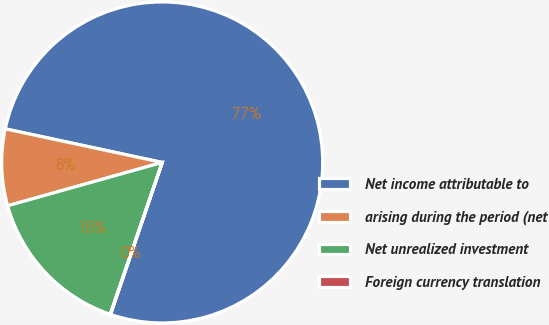<chart> <loc_0><loc_0><loc_500><loc_500><pie_chart><fcel>Net income attributable to<fcel>arising during the period (net<fcel>Net unrealized investment<fcel>Foreign currency translation<nl><fcel>76.86%<fcel>7.71%<fcel>15.4%<fcel>0.03%<nl></chart> 